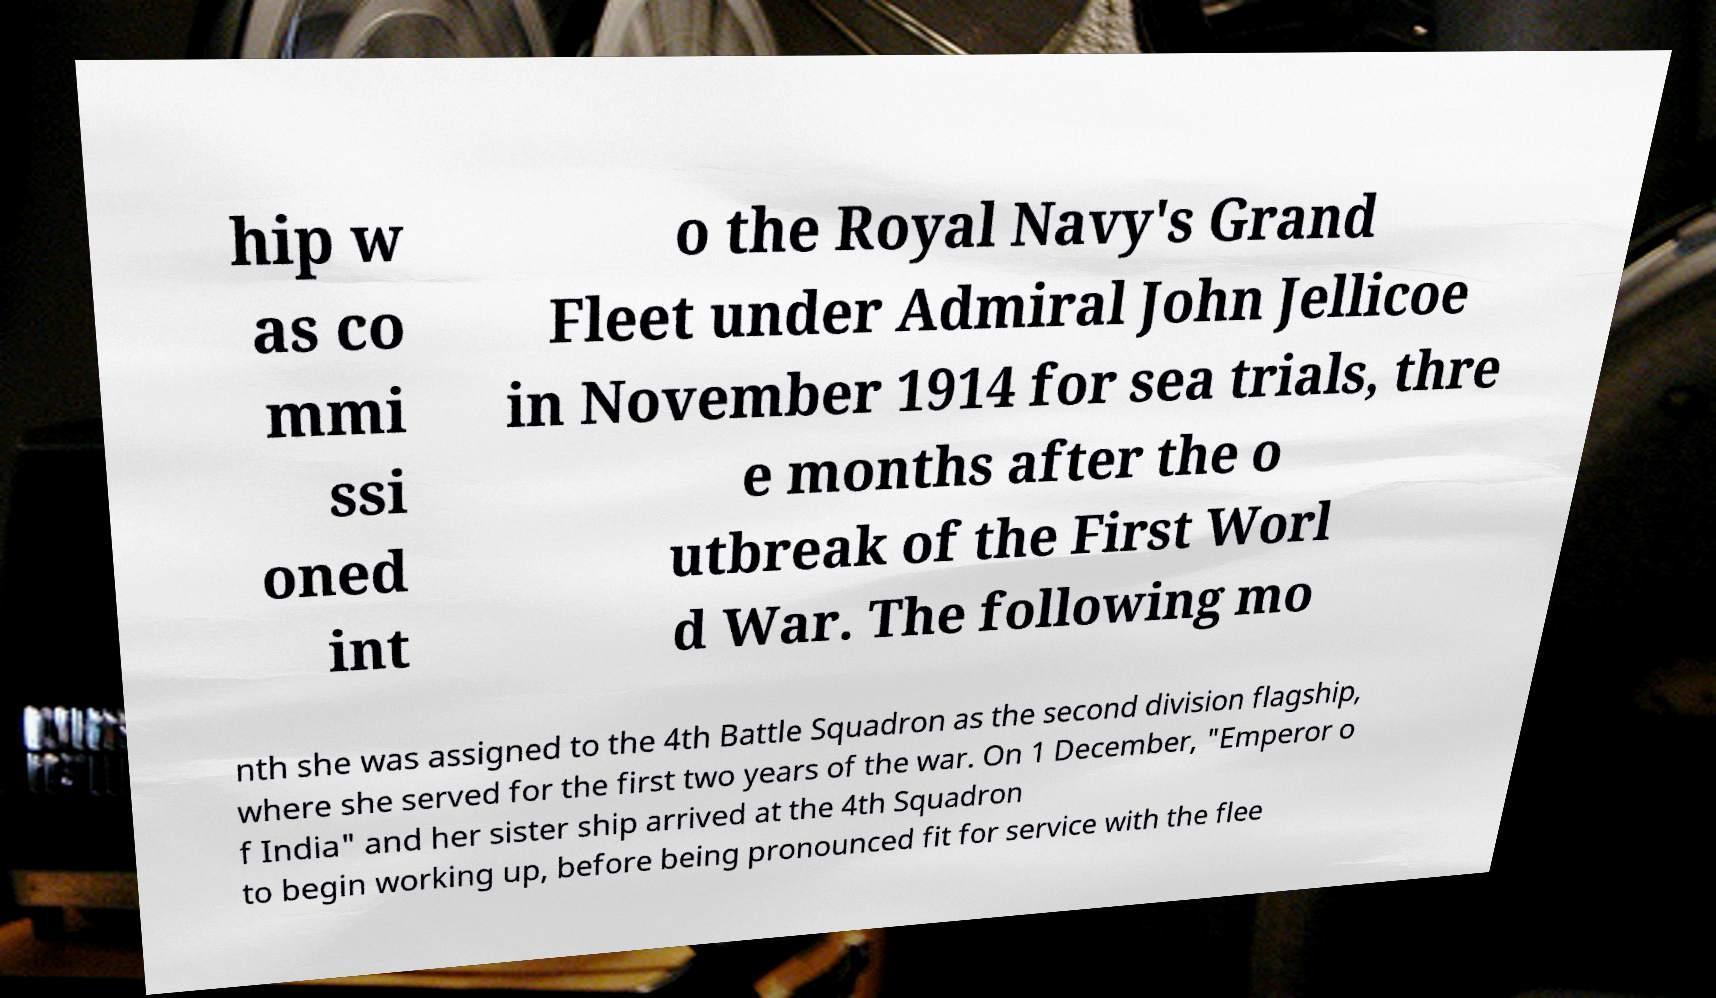Could you extract and type out the text from this image? hip w as co mmi ssi oned int o the Royal Navy's Grand Fleet under Admiral John Jellicoe in November 1914 for sea trials, thre e months after the o utbreak of the First Worl d War. The following mo nth she was assigned to the 4th Battle Squadron as the second division flagship, where she served for the first two years of the war. On 1 December, "Emperor o f India" and her sister ship arrived at the 4th Squadron to begin working up, before being pronounced fit for service with the flee 